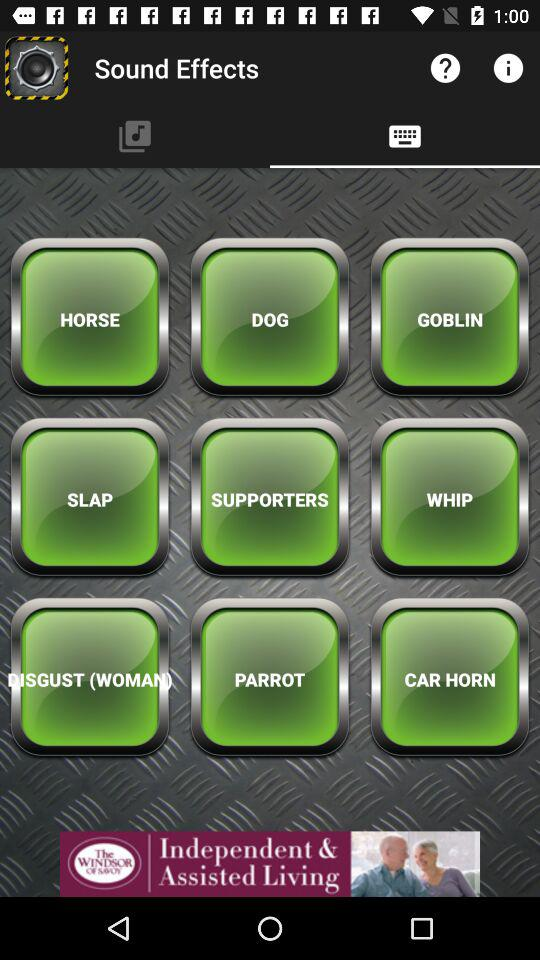Which are the different sound effects? The different sound effects are "HORSE", "DOG", "GOBLIN", "SLAP", "SUPPORTERS", "WHIP", "DISGUST (WOMAN)", "PARROT" and "CAR HORN". 